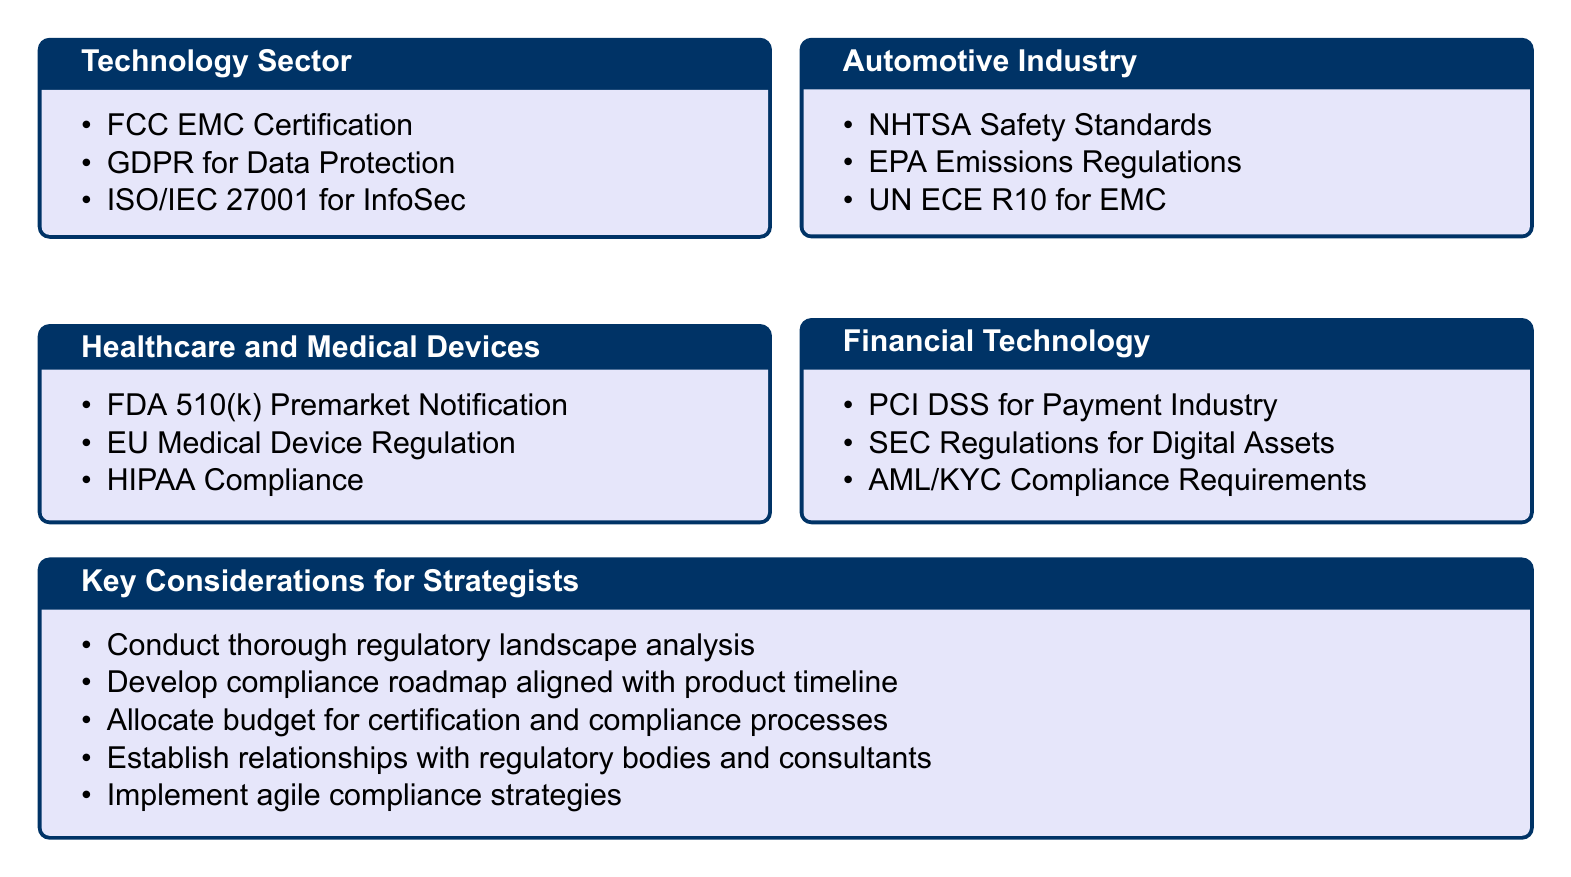What is the title of the document? The title is prominently displayed at the top of the document, indicating the focus on industry regulations and compliance.
Answer: Industry Regulations and Compliance What is one compliance requirement in the Healthcare and Medical Devices sector? Specific compliance requirements for this sector can be found listed under that section in the document.
Answer: FDA 510(k) Premarket Notification Which regulation is associated with the Financial Technology sector? The document includes a list of regulations pertinent to each industry, highlighting key compliance requirements.
Answer: PCI DSS for Payment Industry How many sectors are covered in the document? The number of sectors is determined by the distinct sections outlined in the compilation.
Answer: Four What should strategists establish relationships with? The document suggests specific actions for strategists, which includes establishing relationships to aid in compliance efforts.
Answer: Regulatory bodies What is a key consideration for developing compliance? This refers to essential strategies noted in the document that should be taken into account during product development.
Answer: Compliance roadmap What regulation addresses emissions in the Automotive Industry? A specific regulation focused on environmental impact within the automotive sector is mentioned in the document.
Answer: EPA Emissions Regulations What document format is used for this catalog? The structure and style of the document adhere to a specific publication format typical for compilations of this nature.
Answer: Article 